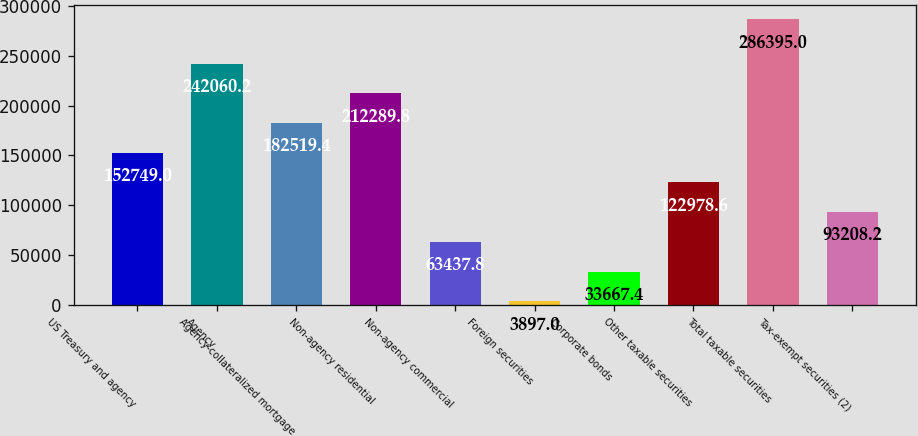Convert chart. <chart><loc_0><loc_0><loc_500><loc_500><bar_chart><fcel>US Treasury and agency<fcel>Agency<fcel>Agency-collateralized mortgage<fcel>Non-agency residential<fcel>Non-agency commercial<fcel>Foreign securities<fcel>Corporate bonds<fcel>Other taxable securities<fcel>Total taxable securities<fcel>Tax-exempt securities (2)<nl><fcel>152749<fcel>242060<fcel>182519<fcel>212290<fcel>63437.8<fcel>3897<fcel>33667.4<fcel>122979<fcel>286395<fcel>93208.2<nl></chart> 